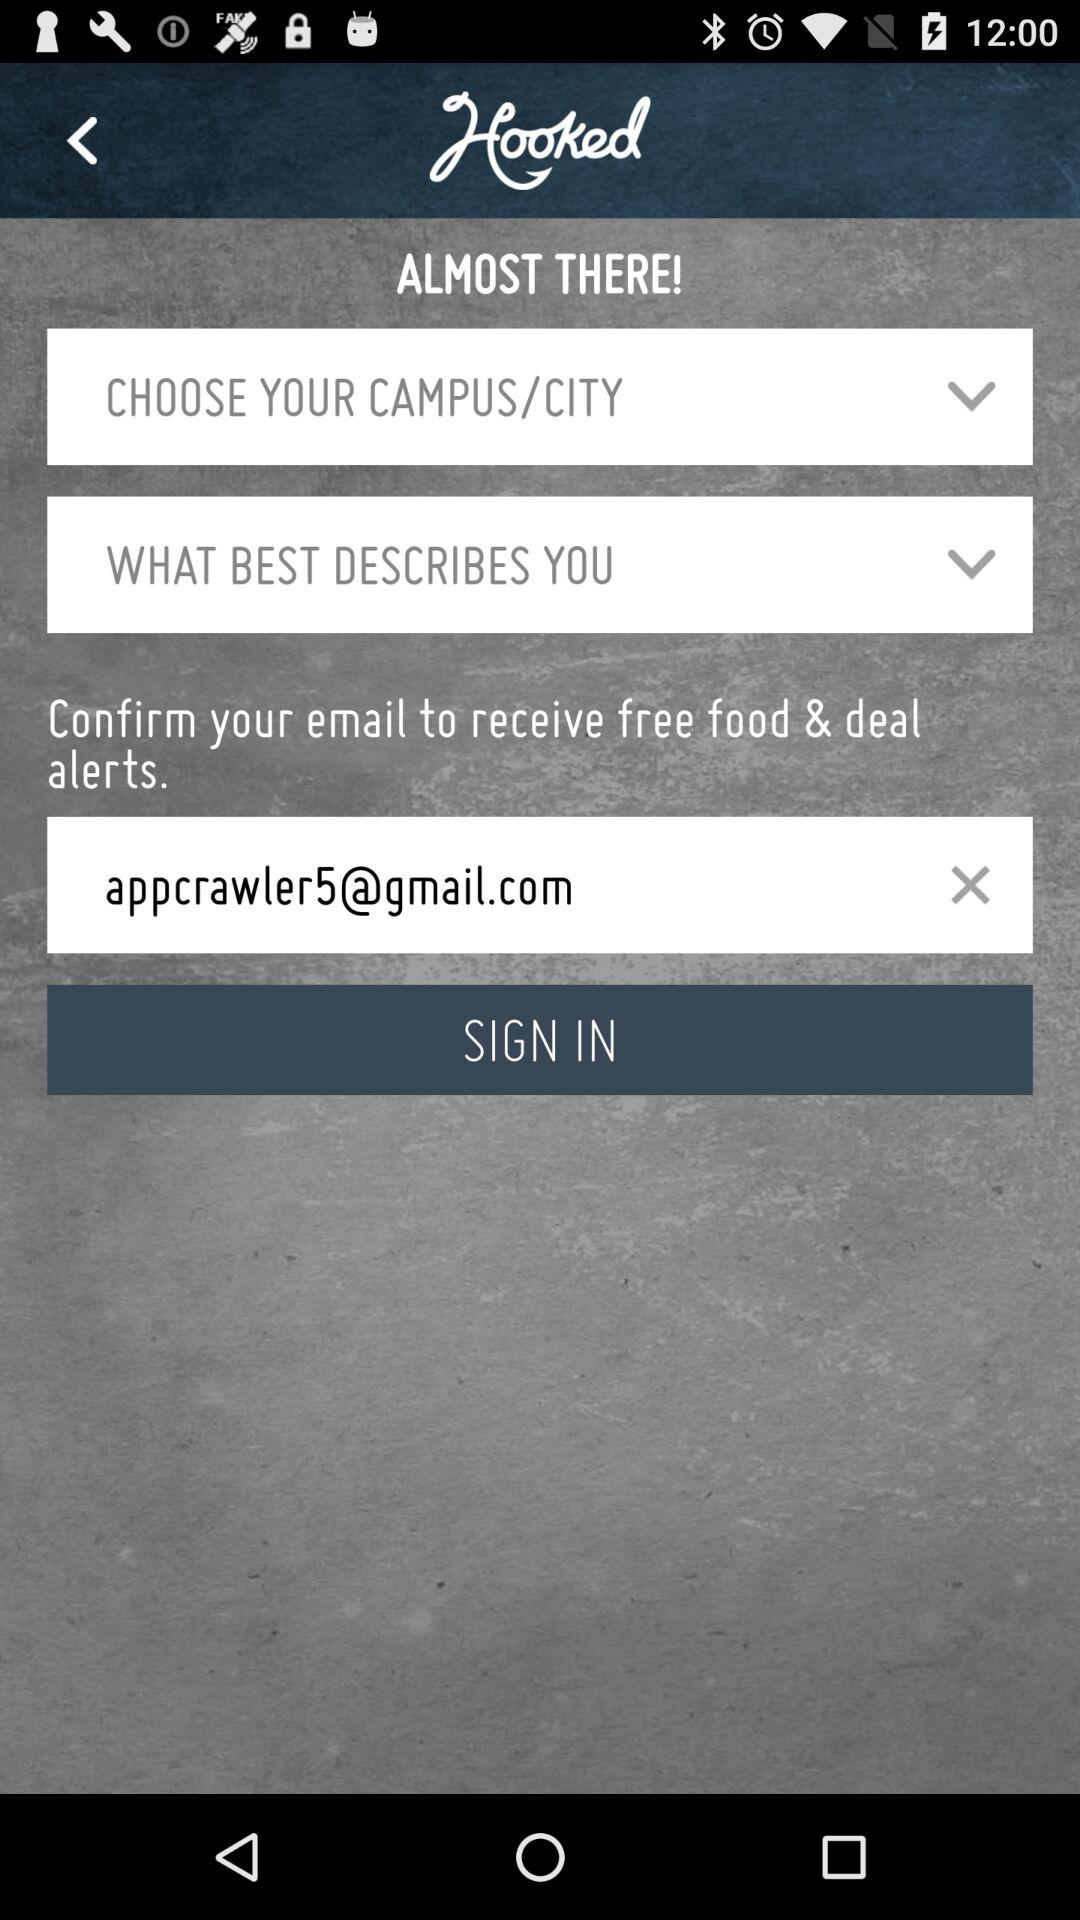What is the name of the application? The name of the application is "Hooked". 